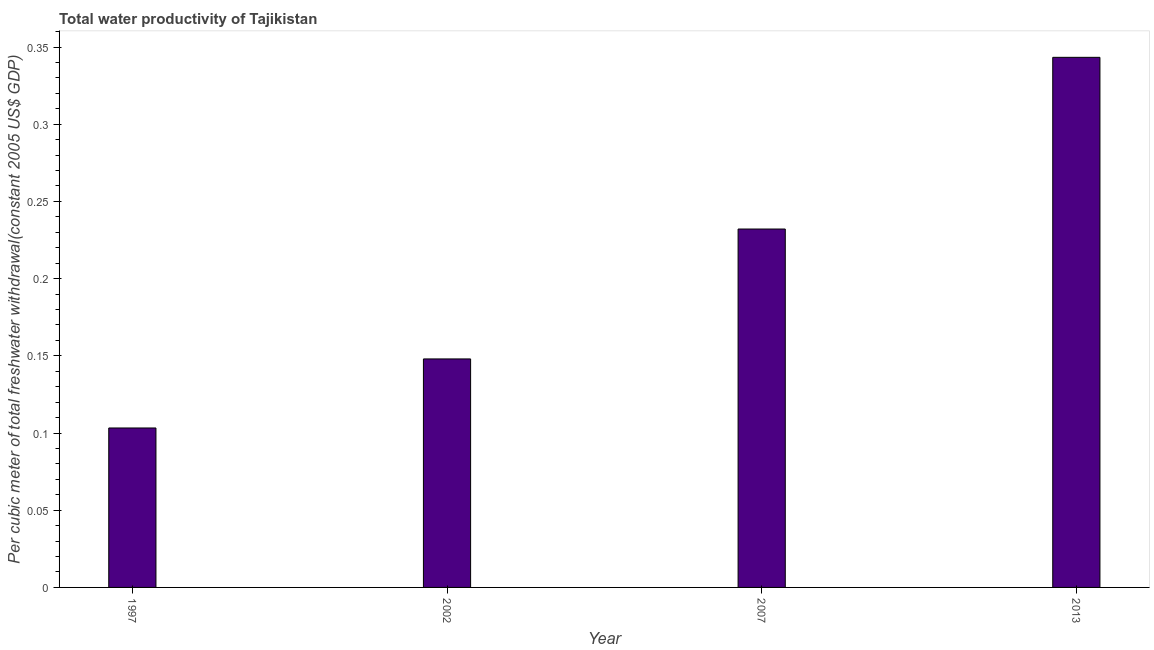Does the graph contain any zero values?
Your answer should be compact. No. Does the graph contain grids?
Ensure brevity in your answer.  No. What is the title of the graph?
Provide a short and direct response. Total water productivity of Tajikistan. What is the label or title of the X-axis?
Offer a very short reply. Year. What is the label or title of the Y-axis?
Ensure brevity in your answer.  Per cubic meter of total freshwater withdrawal(constant 2005 US$ GDP). What is the total water productivity in 2002?
Your answer should be compact. 0.15. Across all years, what is the maximum total water productivity?
Keep it short and to the point. 0.34. Across all years, what is the minimum total water productivity?
Provide a succinct answer. 0.1. In which year was the total water productivity maximum?
Offer a terse response. 2013. In which year was the total water productivity minimum?
Ensure brevity in your answer.  1997. What is the sum of the total water productivity?
Ensure brevity in your answer.  0.83. What is the difference between the total water productivity in 1997 and 2013?
Your answer should be compact. -0.24. What is the average total water productivity per year?
Your answer should be very brief. 0.21. What is the median total water productivity?
Your answer should be compact. 0.19. In how many years, is the total water productivity greater than 0.24 US$?
Offer a terse response. 1. What is the ratio of the total water productivity in 1997 to that in 2002?
Your response must be concise. 0.7. What is the difference between the highest and the second highest total water productivity?
Offer a terse response. 0.11. Is the sum of the total water productivity in 2007 and 2013 greater than the maximum total water productivity across all years?
Make the answer very short. Yes. What is the difference between the highest and the lowest total water productivity?
Keep it short and to the point. 0.24. In how many years, is the total water productivity greater than the average total water productivity taken over all years?
Give a very brief answer. 2. Are all the bars in the graph horizontal?
Provide a succinct answer. No. How many years are there in the graph?
Provide a short and direct response. 4. What is the difference between two consecutive major ticks on the Y-axis?
Keep it short and to the point. 0.05. What is the Per cubic meter of total freshwater withdrawal(constant 2005 US$ GDP) in 1997?
Give a very brief answer. 0.1. What is the Per cubic meter of total freshwater withdrawal(constant 2005 US$ GDP) of 2002?
Offer a very short reply. 0.15. What is the Per cubic meter of total freshwater withdrawal(constant 2005 US$ GDP) of 2007?
Your answer should be very brief. 0.23. What is the Per cubic meter of total freshwater withdrawal(constant 2005 US$ GDP) in 2013?
Offer a very short reply. 0.34. What is the difference between the Per cubic meter of total freshwater withdrawal(constant 2005 US$ GDP) in 1997 and 2002?
Ensure brevity in your answer.  -0.04. What is the difference between the Per cubic meter of total freshwater withdrawal(constant 2005 US$ GDP) in 1997 and 2007?
Ensure brevity in your answer.  -0.13. What is the difference between the Per cubic meter of total freshwater withdrawal(constant 2005 US$ GDP) in 1997 and 2013?
Offer a terse response. -0.24. What is the difference between the Per cubic meter of total freshwater withdrawal(constant 2005 US$ GDP) in 2002 and 2007?
Offer a terse response. -0.08. What is the difference between the Per cubic meter of total freshwater withdrawal(constant 2005 US$ GDP) in 2002 and 2013?
Your response must be concise. -0.2. What is the difference between the Per cubic meter of total freshwater withdrawal(constant 2005 US$ GDP) in 2007 and 2013?
Offer a terse response. -0.11. What is the ratio of the Per cubic meter of total freshwater withdrawal(constant 2005 US$ GDP) in 1997 to that in 2002?
Ensure brevity in your answer.  0.7. What is the ratio of the Per cubic meter of total freshwater withdrawal(constant 2005 US$ GDP) in 1997 to that in 2007?
Provide a short and direct response. 0.45. What is the ratio of the Per cubic meter of total freshwater withdrawal(constant 2005 US$ GDP) in 1997 to that in 2013?
Give a very brief answer. 0.3. What is the ratio of the Per cubic meter of total freshwater withdrawal(constant 2005 US$ GDP) in 2002 to that in 2007?
Your response must be concise. 0.64. What is the ratio of the Per cubic meter of total freshwater withdrawal(constant 2005 US$ GDP) in 2002 to that in 2013?
Your response must be concise. 0.43. What is the ratio of the Per cubic meter of total freshwater withdrawal(constant 2005 US$ GDP) in 2007 to that in 2013?
Offer a terse response. 0.68. 